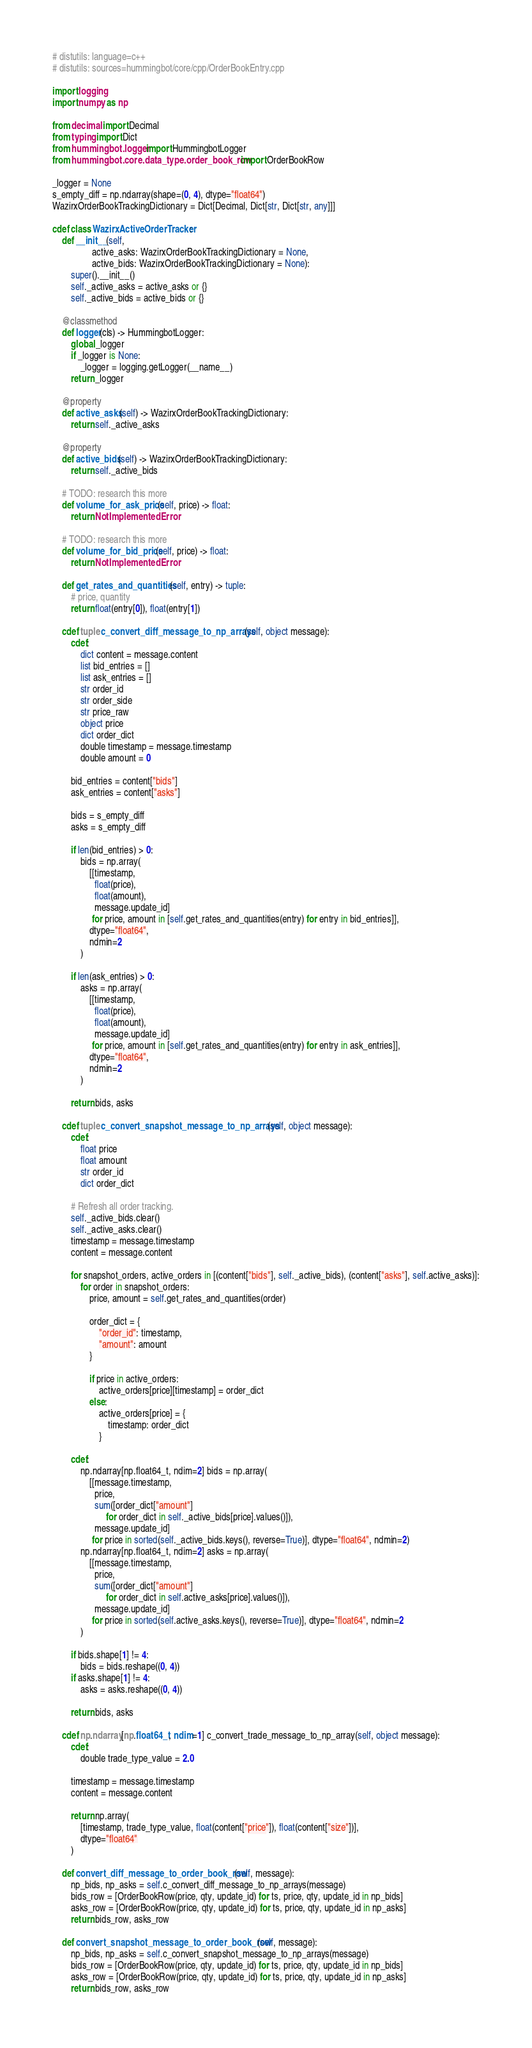Convert code to text. <code><loc_0><loc_0><loc_500><loc_500><_Cython_># distutils: language=c++
# distutils: sources=hummingbot/core/cpp/OrderBookEntry.cpp

import logging
import numpy as np

from decimal import Decimal
from typing import Dict
from hummingbot.logger import HummingbotLogger
from hummingbot.core.data_type.order_book_row import OrderBookRow

_logger = None
s_empty_diff = np.ndarray(shape=(0, 4), dtype="float64")
WazirxOrderBookTrackingDictionary = Dict[Decimal, Dict[str, Dict[str, any]]]

cdef class WazirxActiveOrderTracker:
    def __init__(self,
                 active_asks: WazirxOrderBookTrackingDictionary = None,
                 active_bids: WazirxOrderBookTrackingDictionary = None):
        super().__init__()
        self._active_asks = active_asks or {}
        self._active_bids = active_bids or {}

    @classmethod
    def logger(cls) -> HummingbotLogger:
        global _logger
        if _logger is None:
            _logger = logging.getLogger(__name__)
        return _logger

    @property
    def active_asks(self) -> WazirxOrderBookTrackingDictionary:
        return self._active_asks

    @property
    def active_bids(self) -> WazirxOrderBookTrackingDictionary:
        return self._active_bids

    # TODO: research this more
    def volume_for_ask_price(self, price) -> float:
        return NotImplementedError

    # TODO: research this more
    def volume_for_bid_price(self, price) -> float:
        return NotImplementedError

    def get_rates_and_quantities(self, entry) -> tuple:
        # price, quantity
        return float(entry[0]), float(entry[1])

    cdef tuple c_convert_diff_message_to_np_arrays(self, object message):
        cdef:
            dict content = message.content
            list bid_entries = []
            list ask_entries = []
            str order_id
            str order_side
            str price_raw
            object price
            dict order_dict
            double timestamp = message.timestamp
            double amount = 0

        bid_entries = content["bids"]
        ask_entries = content["asks"]

        bids = s_empty_diff
        asks = s_empty_diff

        if len(bid_entries) > 0:
            bids = np.array(
                [[timestamp,
                  float(price),
                  float(amount),
                  message.update_id]
                 for price, amount in [self.get_rates_and_quantities(entry) for entry in bid_entries]],
                dtype="float64",
                ndmin=2
            )

        if len(ask_entries) > 0:
            asks = np.array(
                [[timestamp,
                  float(price),
                  float(amount),
                  message.update_id]
                 for price, amount in [self.get_rates_and_quantities(entry) for entry in ask_entries]],
                dtype="float64",
                ndmin=2
            )

        return bids, asks

    cdef tuple c_convert_snapshot_message_to_np_arrays(self, object message):
        cdef:
            float price
            float amount
            str order_id
            dict order_dict

        # Refresh all order tracking.
        self._active_bids.clear()
        self._active_asks.clear()
        timestamp = message.timestamp
        content = message.content

        for snapshot_orders, active_orders in [(content["bids"], self._active_bids), (content["asks"], self.active_asks)]:
            for order in snapshot_orders:
                price, amount = self.get_rates_and_quantities(order)

                order_dict = {
                    "order_id": timestamp,
                    "amount": amount
                }

                if price in active_orders:
                    active_orders[price][timestamp] = order_dict
                else:
                    active_orders[price] = {
                        timestamp: order_dict
                    }

        cdef:
            np.ndarray[np.float64_t, ndim=2] bids = np.array(
                [[message.timestamp,
                  price,
                  sum([order_dict["amount"]
                       for order_dict in self._active_bids[price].values()]),
                  message.update_id]
                 for price in sorted(self._active_bids.keys(), reverse=True)], dtype="float64", ndmin=2)
            np.ndarray[np.float64_t, ndim=2] asks = np.array(
                [[message.timestamp,
                  price,
                  sum([order_dict["amount"]
                       for order_dict in self.active_asks[price].values()]),
                  message.update_id]
                 for price in sorted(self.active_asks.keys(), reverse=True)], dtype="float64", ndmin=2
            )

        if bids.shape[1] != 4:
            bids = bids.reshape((0, 4))
        if asks.shape[1] != 4:
            asks = asks.reshape((0, 4))

        return bids, asks

    cdef np.ndarray[np.float64_t, ndim=1] c_convert_trade_message_to_np_array(self, object message):
        cdef:
            double trade_type_value = 2.0

        timestamp = message.timestamp
        content = message.content

        return np.array(
            [timestamp, trade_type_value, float(content["price"]), float(content["size"])],
            dtype="float64"
        )

    def convert_diff_message_to_order_book_row(self, message):
        np_bids, np_asks = self.c_convert_diff_message_to_np_arrays(message)
        bids_row = [OrderBookRow(price, qty, update_id) for ts, price, qty, update_id in np_bids]
        asks_row = [OrderBookRow(price, qty, update_id) for ts, price, qty, update_id in np_asks]
        return bids_row, asks_row

    def convert_snapshot_message_to_order_book_row(self, message):
        np_bids, np_asks = self.c_convert_snapshot_message_to_np_arrays(message)
        bids_row = [OrderBookRow(price, qty, update_id) for ts, price, qty, update_id in np_bids]
        asks_row = [OrderBookRow(price, qty, update_id) for ts, price, qty, update_id in np_asks]
        return bids_row, asks_row
</code> 